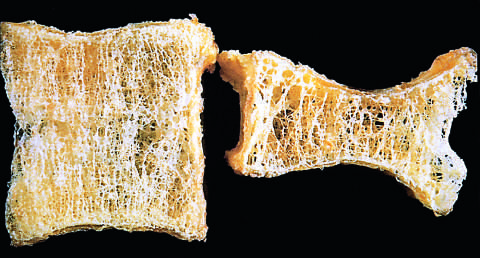s steoporotic vertebral body shorten by compression fractures?
Answer the question using a single word or phrase. Yes 